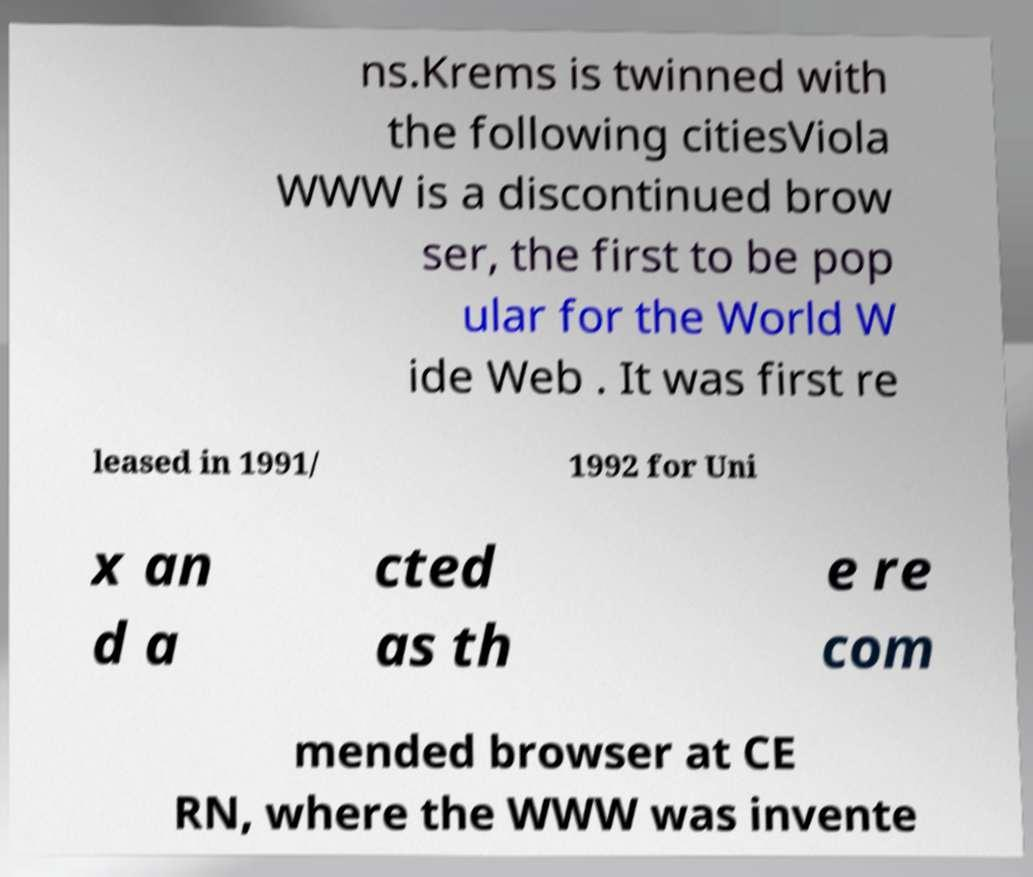Could you assist in decoding the text presented in this image and type it out clearly? ns.Krems is twinned with the following citiesViola WWW is a discontinued brow ser, the first to be pop ular for the World W ide Web . It was first re leased in 1991/ 1992 for Uni x an d a cted as th e re com mended browser at CE RN, where the WWW was invente 